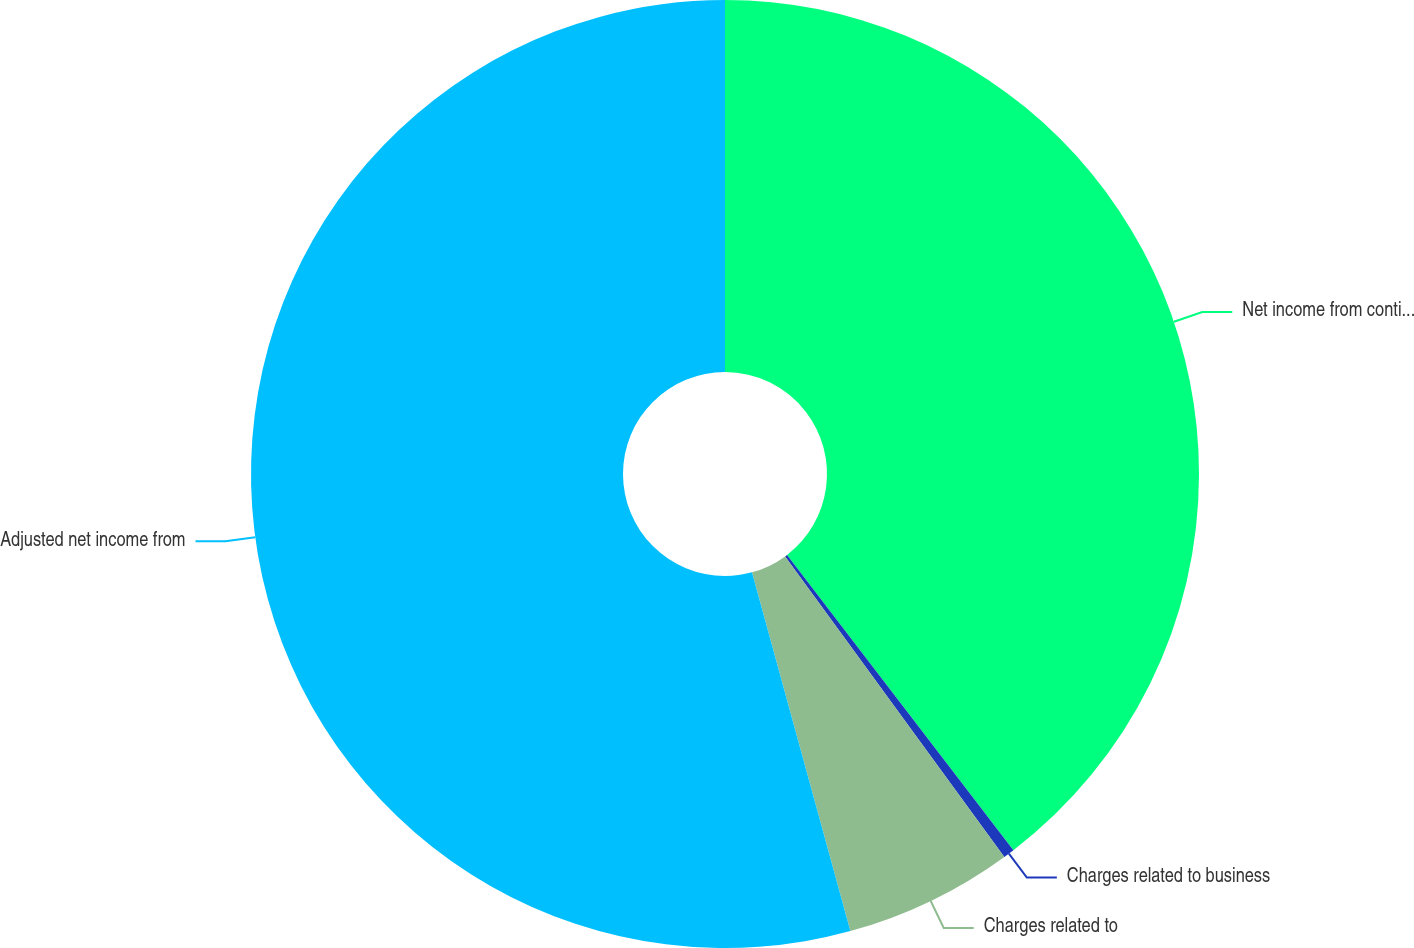<chart> <loc_0><loc_0><loc_500><loc_500><pie_chart><fcel>Net income from continuing<fcel>Charges related to business<fcel>Charges related to<fcel>Adjusted net income from<nl><fcel>39.59%<fcel>0.38%<fcel>5.77%<fcel>54.26%<nl></chart> 